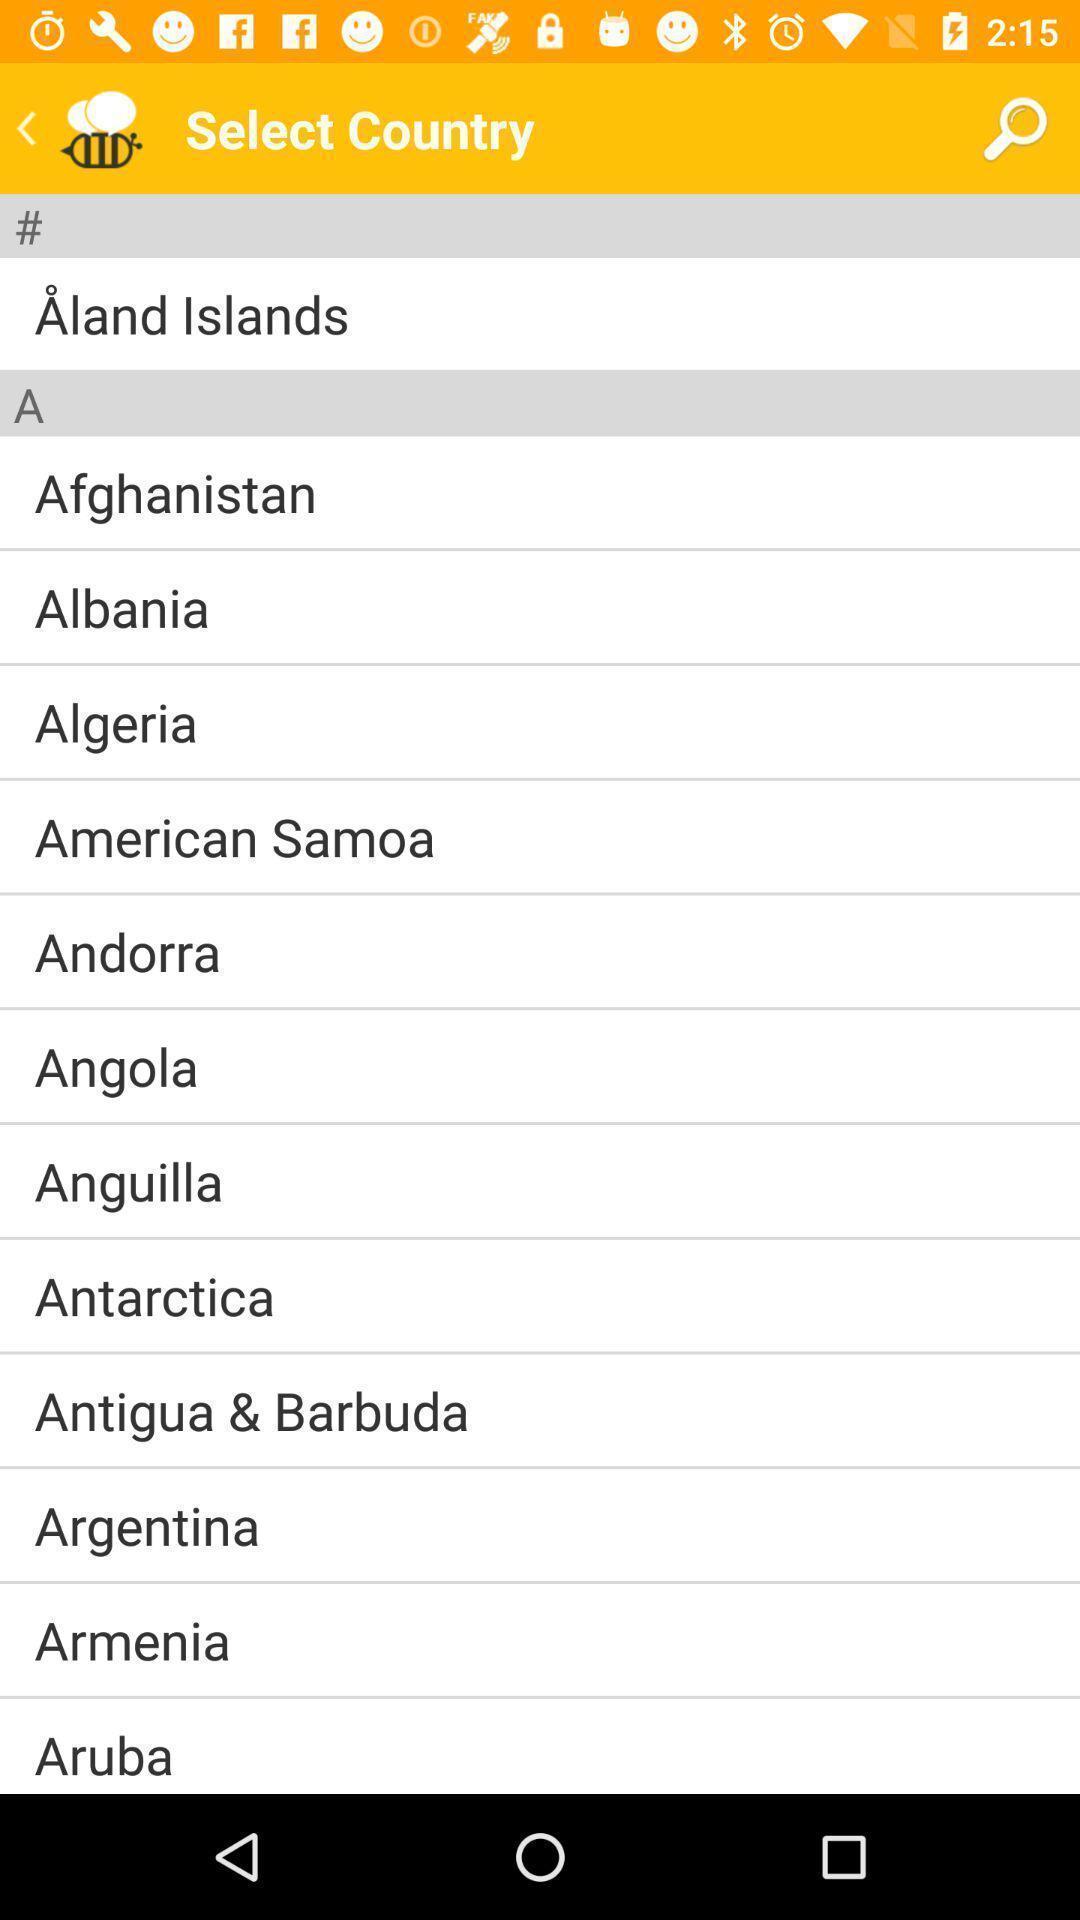Provide a description of this screenshot. Screen displays to select a country. 